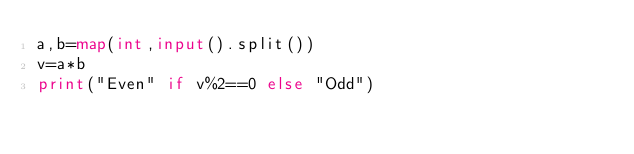Convert code to text. <code><loc_0><loc_0><loc_500><loc_500><_Python_>a,b=map(int,input().split())
v=a*b
print("Even" if v%2==0 else "Odd")
</code> 